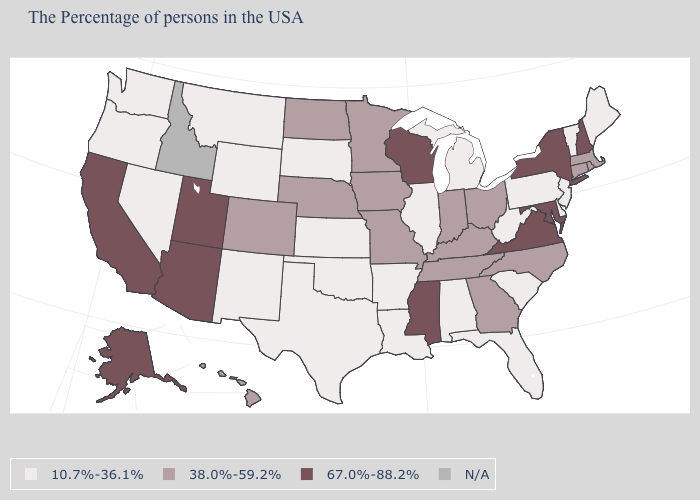Is the legend a continuous bar?
Be succinct. No. How many symbols are there in the legend?
Answer briefly. 4. What is the value of Colorado?
Be succinct. 38.0%-59.2%. What is the value of Ohio?
Write a very short answer. 38.0%-59.2%. Does Colorado have the lowest value in the USA?
Concise answer only. No. Among the states that border Idaho , does Oregon have the lowest value?
Keep it brief. Yes. Does Massachusetts have the lowest value in the Northeast?
Write a very short answer. No. Name the states that have a value in the range 10.7%-36.1%?
Be succinct. Maine, Vermont, New Jersey, Delaware, Pennsylvania, South Carolina, West Virginia, Florida, Michigan, Alabama, Illinois, Louisiana, Arkansas, Kansas, Oklahoma, Texas, South Dakota, Wyoming, New Mexico, Montana, Nevada, Washington, Oregon. Among the states that border Georgia , which have the highest value?
Write a very short answer. North Carolina, Tennessee. What is the lowest value in the West?
Keep it brief. 10.7%-36.1%. Name the states that have a value in the range N/A?
Short answer required. Idaho. Does Delaware have the highest value in the South?
Quick response, please. No. What is the value of Kentucky?
Give a very brief answer. 38.0%-59.2%. 